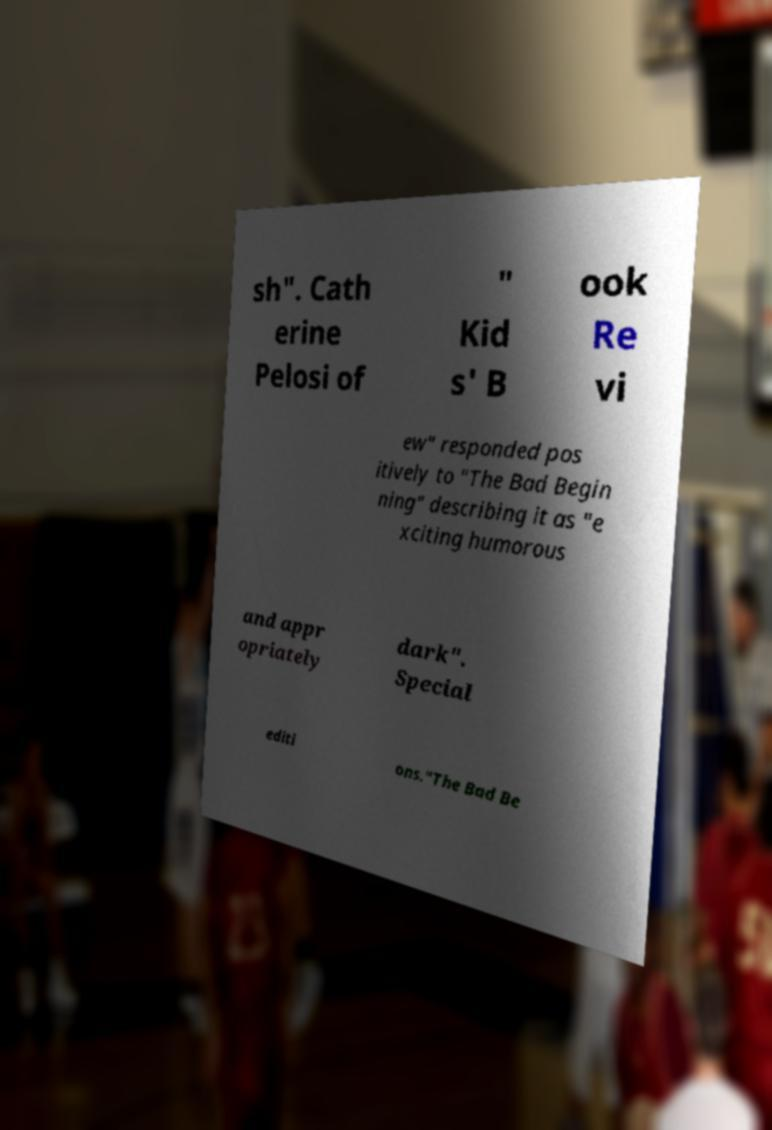There's text embedded in this image that I need extracted. Can you transcribe it verbatim? sh". Cath erine Pelosi of " Kid s' B ook Re vi ew" responded pos itively to "The Bad Begin ning" describing it as "e xciting humorous and appr opriately dark". Special editi ons."The Bad Be 